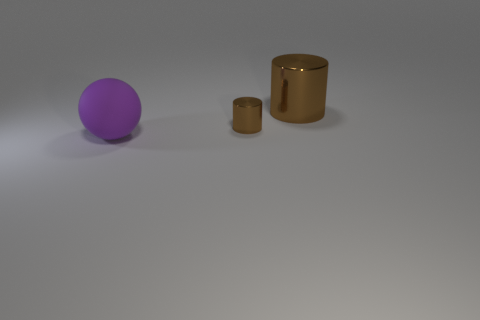Add 3 big brown things. How many objects exist? 6 Subtract all spheres. How many objects are left? 2 Subtract all gray metallic spheres. Subtract all large brown metallic objects. How many objects are left? 2 Add 3 rubber objects. How many rubber objects are left? 4 Add 1 large shiny objects. How many large shiny objects exist? 2 Subtract 1 brown cylinders. How many objects are left? 2 Subtract 2 cylinders. How many cylinders are left? 0 Subtract all cyan cylinders. Subtract all yellow balls. How many cylinders are left? 2 